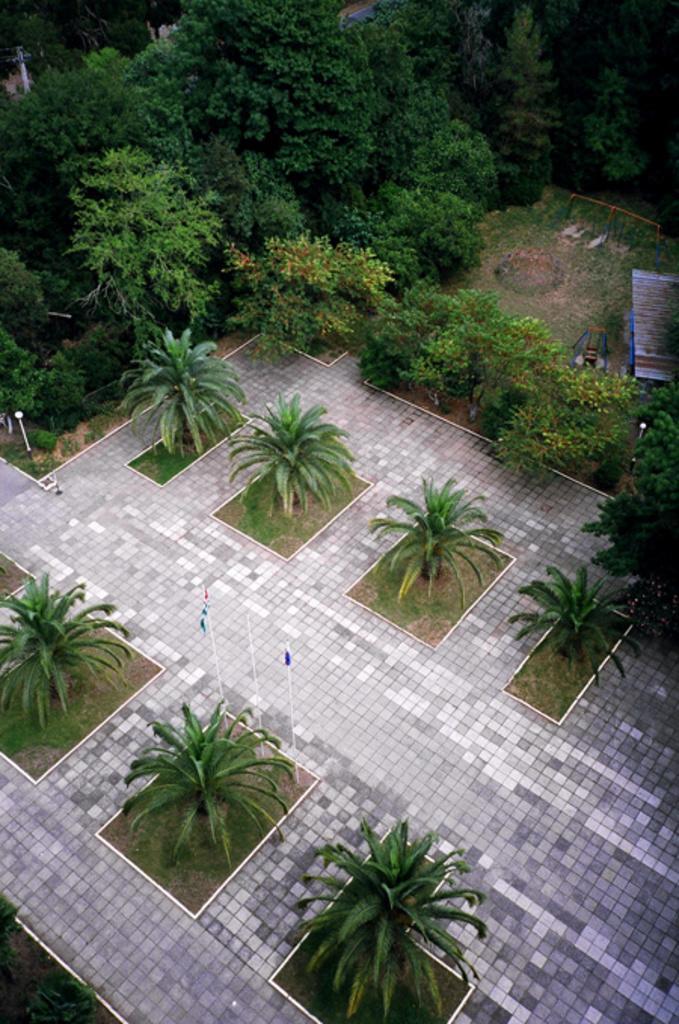Could you give a brief overview of what you see in this image? In this image we can see flooring, trees and flags. On the right there is a bench. 